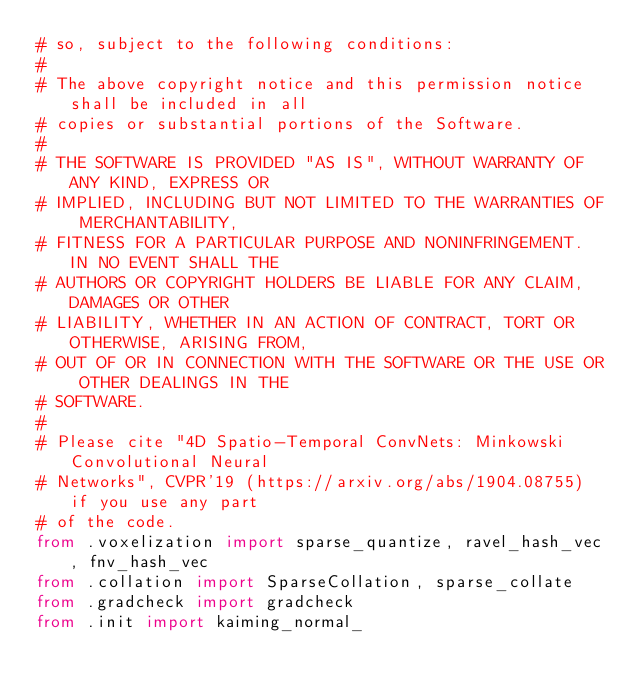<code> <loc_0><loc_0><loc_500><loc_500><_Python_># so, subject to the following conditions:
#
# The above copyright notice and this permission notice shall be included in all
# copies or substantial portions of the Software.
#
# THE SOFTWARE IS PROVIDED "AS IS", WITHOUT WARRANTY OF ANY KIND, EXPRESS OR
# IMPLIED, INCLUDING BUT NOT LIMITED TO THE WARRANTIES OF MERCHANTABILITY,
# FITNESS FOR A PARTICULAR PURPOSE AND NONINFRINGEMENT. IN NO EVENT SHALL THE
# AUTHORS OR COPYRIGHT HOLDERS BE LIABLE FOR ANY CLAIM, DAMAGES OR OTHER
# LIABILITY, WHETHER IN AN ACTION OF CONTRACT, TORT OR OTHERWISE, ARISING FROM,
# OUT OF OR IN CONNECTION WITH THE SOFTWARE OR THE USE OR OTHER DEALINGS IN THE
# SOFTWARE.
#
# Please cite "4D Spatio-Temporal ConvNets: Minkowski Convolutional Neural
# Networks", CVPR'19 (https://arxiv.org/abs/1904.08755) if you use any part
# of the code.
from .voxelization import sparse_quantize, ravel_hash_vec, fnv_hash_vec
from .collation import SparseCollation, sparse_collate
from .gradcheck import gradcheck
from .init import kaiming_normal_
</code> 